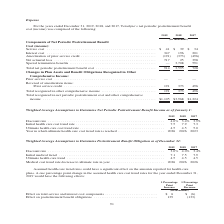According to Teradyne's financial document, What was the service cost in 2019? According to the financial document, $41 (in thousands). The relevant text states: "etirement Benefit Cost (income): Service cost . $ 41 $ 39 $ 34 Interest cost . 347 196 201 Amortization of prior service credit . (191) (373) (496) Net..." Also, What was the interest cost in 2019? According to the financial document, 347 (in thousands). The relevant text states: "e): Service cost . $ 41 $ 39 $ 34 Interest cost . 347 196 201 Amortization of prior service credit . (191) (373) (496) Net actuarial loss . 717 25 398 Sp..." Also, For which years was  Teradyne’s net periodic postretirement benefit cost (income) calculated? The document contains multiple relevant values: 2019, 2018, 2017. From the document: "2019 2018 2017 2019 2018 2017 2019 2018 2017..." Additionally, In which year was service cost the largest? According to the financial document, 2019. The relevant text states: "2019 2018 2017..." Also, can you calculate: What was the change in service cost in 2018 from 2017? Based on the calculation: 39-34, the result is 5 (in thousands). This is based on the information: "ment Benefit Cost (income): Service cost . $ 41 $ 39 $ 34 Interest cost . 347 196 201 Amortization of prior service credit . (191) (373) (496) Net actua Benefit Cost (income): Service cost . $ 41 $ 39..." The key data points involved are: 34, 39. Also, can you calculate: What was the percentage change in service cost in 2018 from 2017? To answer this question, I need to perform calculations using the financial data. The calculation is: (39-34)/34, which equals 14.71 (percentage). This is based on the information: "ment Benefit Cost (income): Service cost . $ 41 $ 39 $ 34 Interest cost . 347 196 201 Amortization of prior service credit . (191) (373) (496) Net actua Benefit Cost (income): Service cost . $ 41 $ 39..." The key data points involved are: 34, 39. 